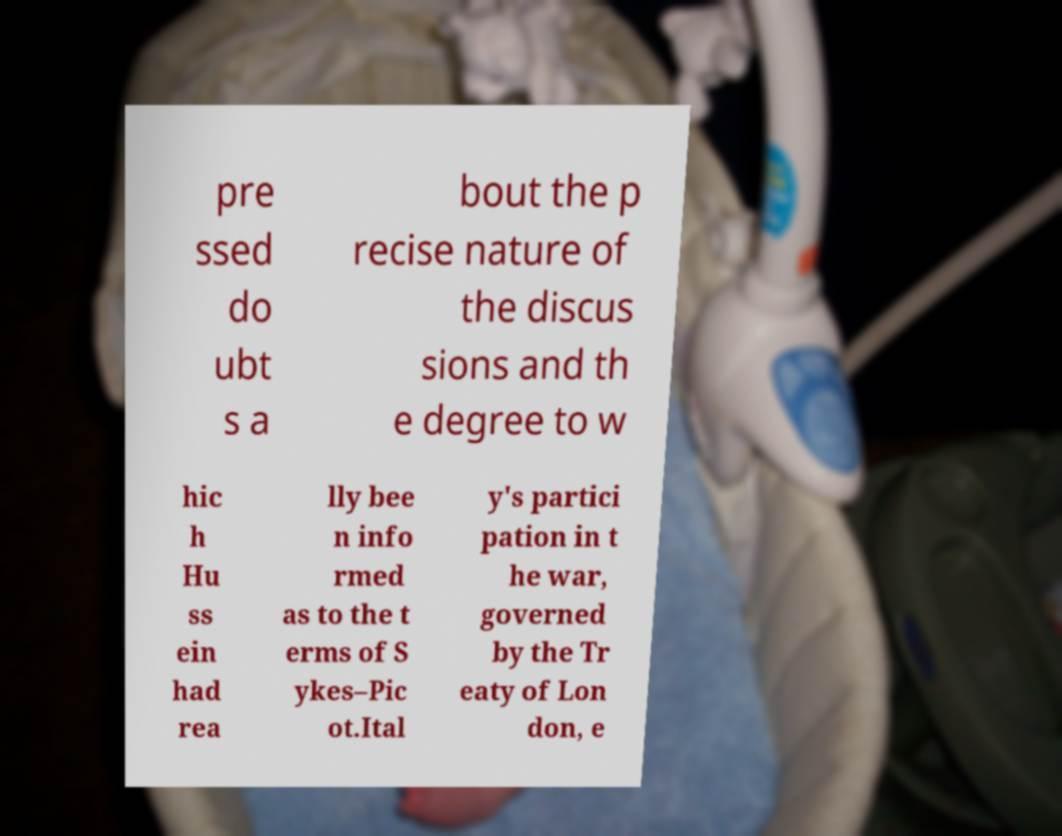For documentation purposes, I need the text within this image transcribed. Could you provide that? pre ssed do ubt s a bout the p recise nature of the discus sions and th e degree to w hic h Hu ss ein had rea lly bee n info rmed as to the t erms of S ykes–Pic ot.Ital y's partici pation in t he war, governed by the Tr eaty of Lon don, e 